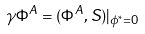<formula> <loc_0><loc_0><loc_500><loc_500>\gamma \Phi ^ { A } = ( \Phi ^ { A } , S ) | _ { \phi ^ { * } = 0 }</formula> 